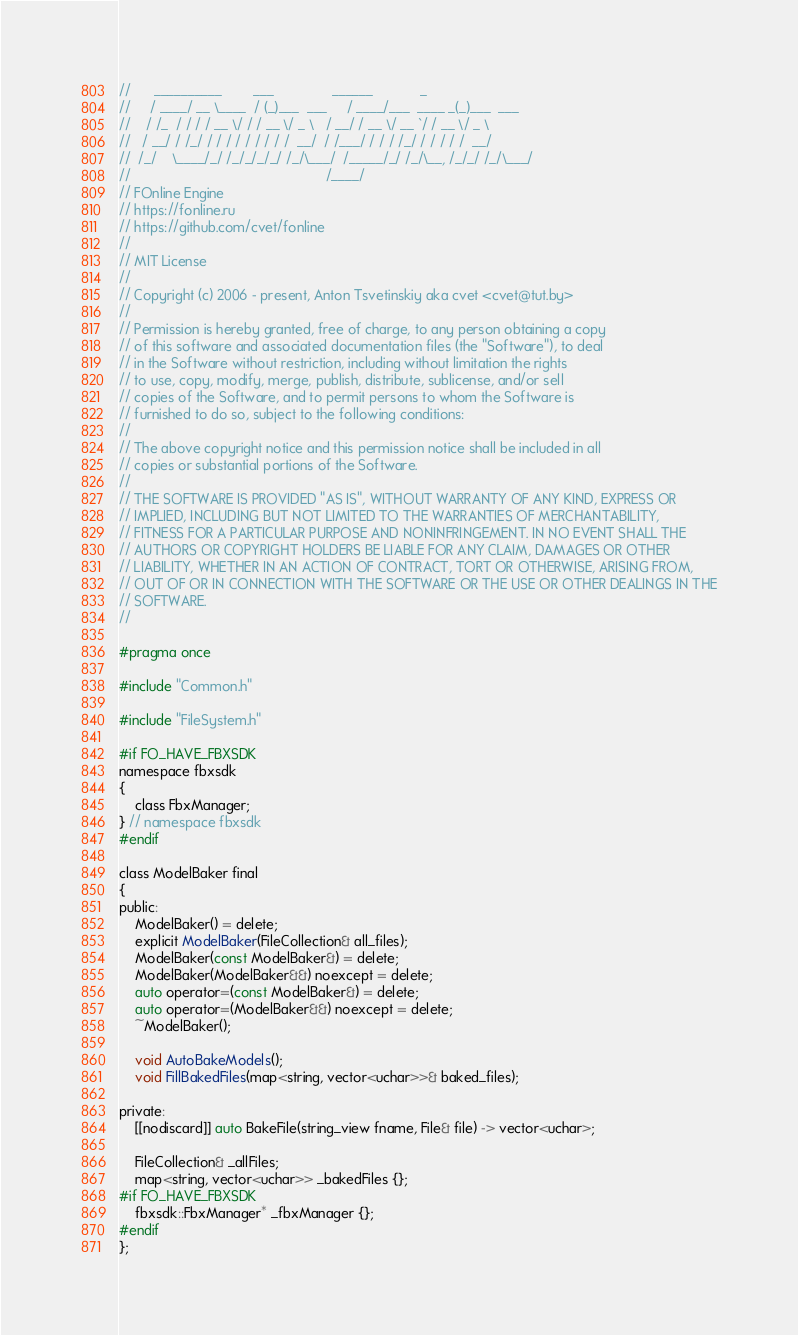Convert code to text. <code><loc_0><loc_0><loc_500><loc_500><_C_>//      __________        ___               ______            _
//     / ____/ __ \____  / (_)___  ___     / ____/___  ____ _(_)___  ___
//    / /_  / / / / __ \/ / / __ \/ _ \   / __/ / __ \/ __ `/ / __ \/ _ \
//   / __/ / /_/ / / / / / / / / /  __/  / /___/ / / / /_/ / / / / /  __/
//  /_/    \____/_/ /_/_/_/_/ /_/\___/  /_____/_/ /_/\__, /_/_/ /_/\___/
//                                                  /____/
// FOnline Engine
// https://fonline.ru
// https://github.com/cvet/fonline
//
// MIT License
//
// Copyright (c) 2006 - present, Anton Tsvetinskiy aka cvet <cvet@tut.by>
//
// Permission is hereby granted, free of charge, to any person obtaining a copy
// of this software and associated documentation files (the "Software"), to deal
// in the Software without restriction, including without limitation the rights
// to use, copy, modify, merge, publish, distribute, sublicense, and/or sell
// copies of the Software, and to permit persons to whom the Software is
// furnished to do so, subject to the following conditions:
//
// The above copyright notice and this permission notice shall be included in all
// copies or substantial portions of the Software.
//
// THE SOFTWARE IS PROVIDED "AS IS", WITHOUT WARRANTY OF ANY KIND, EXPRESS OR
// IMPLIED, INCLUDING BUT NOT LIMITED TO THE WARRANTIES OF MERCHANTABILITY,
// FITNESS FOR A PARTICULAR PURPOSE AND NONINFRINGEMENT. IN NO EVENT SHALL THE
// AUTHORS OR COPYRIGHT HOLDERS BE LIABLE FOR ANY CLAIM, DAMAGES OR OTHER
// LIABILITY, WHETHER IN AN ACTION OF CONTRACT, TORT OR OTHERWISE, ARISING FROM,
// OUT OF OR IN CONNECTION WITH THE SOFTWARE OR THE USE OR OTHER DEALINGS IN THE
// SOFTWARE.
//

#pragma once

#include "Common.h"

#include "FileSystem.h"

#if FO_HAVE_FBXSDK
namespace fbxsdk
{
    class FbxManager;
} // namespace fbxsdk
#endif

class ModelBaker final
{
public:
    ModelBaker() = delete;
    explicit ModelBaker(FileCollection& all_files);
    ModelBaker(const ModelBaker&) = delete;
    ModelBaker(ModelBaker&&) noexcept = delete;
    auto operator=(const ModelBaker&) = delete;
    auto operator=(ModelBaker&&) noexcept = delete;
    ~ModelBaker();

    void AutoBakeModels();
    void FillBakedFiles(map<string, vector<uchar>>& baked_files);

private:
    [[nodiscard]] auto BakeFile(string_view fname, File& file) -> vector<uchar>;

    FileCollection& _allFiles;
    map<string, vector<uchar>> _bakedFiles {};
#if FO_HAVE_FBXSDK
    fbxsdk::FbxManager* _fbxManager {};
#endif
};
</code> 